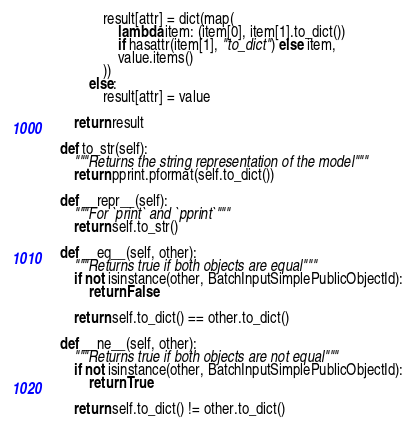<code> <loc_0><loc_0><loc_500><loc_500><_Python_>                result[attr] = dict(map(
                    lambda item: (item[0], item[1].to_dict())
                    if hasattr(item[1], "to_dict") else item,
                    value.items()
                ))
            else:
                result[attr] = value

        return result

    def to_str(self):
        """Returns the string representation of the model"""
        return pprint.pformat(self.to_dict())

    def __repr__(self):
        """For `print` and `pprint`"""
        return self.to_str()

    def __eq__(self, other):
        """Returns true if both objects are equal"""
        if not isinstance(other, BatchInputSimplePublicObjectId):
            return False

        return self.to_dict() == other.to_dict()

    def __ne__(self, other):
        """Returns true if both objects are not equal"""
        if not isinstance(other, BatchInputSimplePublicObjectId):
            return True

        return self.to_dict() != other.to_dict()
</code> 